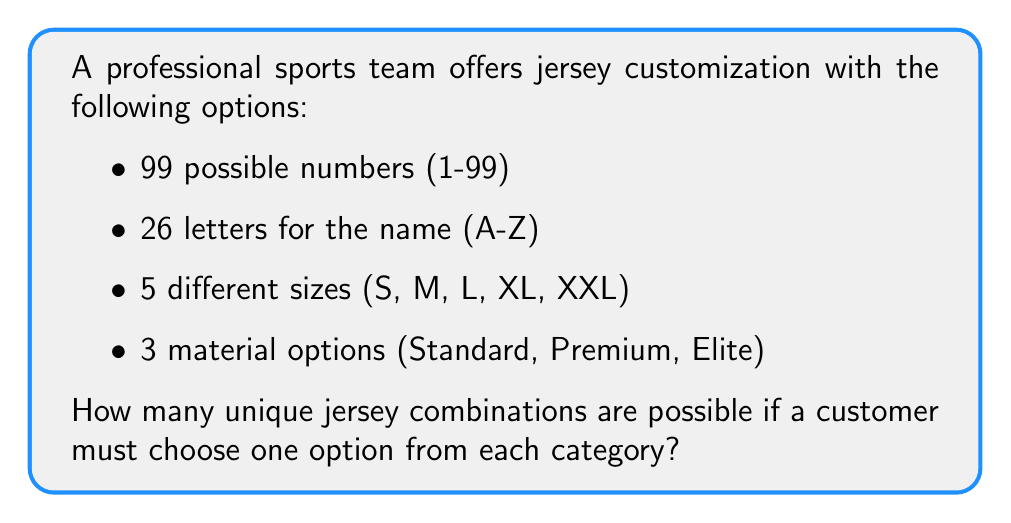Give your solution to this math problem. To solve this problem, we'll use the multiplication principle of counting. Since we're selecting one option from each category independently, we multiply the number of choices for each category:

1. Numbers: There are 99 possible numbers to choose from.
2. Letters: For simplicity, we'll assume a single-letter name. There are 26 letters to choose from.
3. Sizes: There are 5 size options available.
4. Materials: There are 3 material options to choose from.

The total number of combinations is:

$$ \text{Total combinations} = 99 \times 26 \times 5 \times 3 $$

Calculating:
$$ 99 \times 26 \times 5 \times 3 = 38,610 $$

Therefore, there are 38,610 possible unique jersey combinations.

Note: This problem doesn't involve college basketball, aligning with the given persona of a sports fan who doesn't follow college basketball.
Answer: $38,610$ 